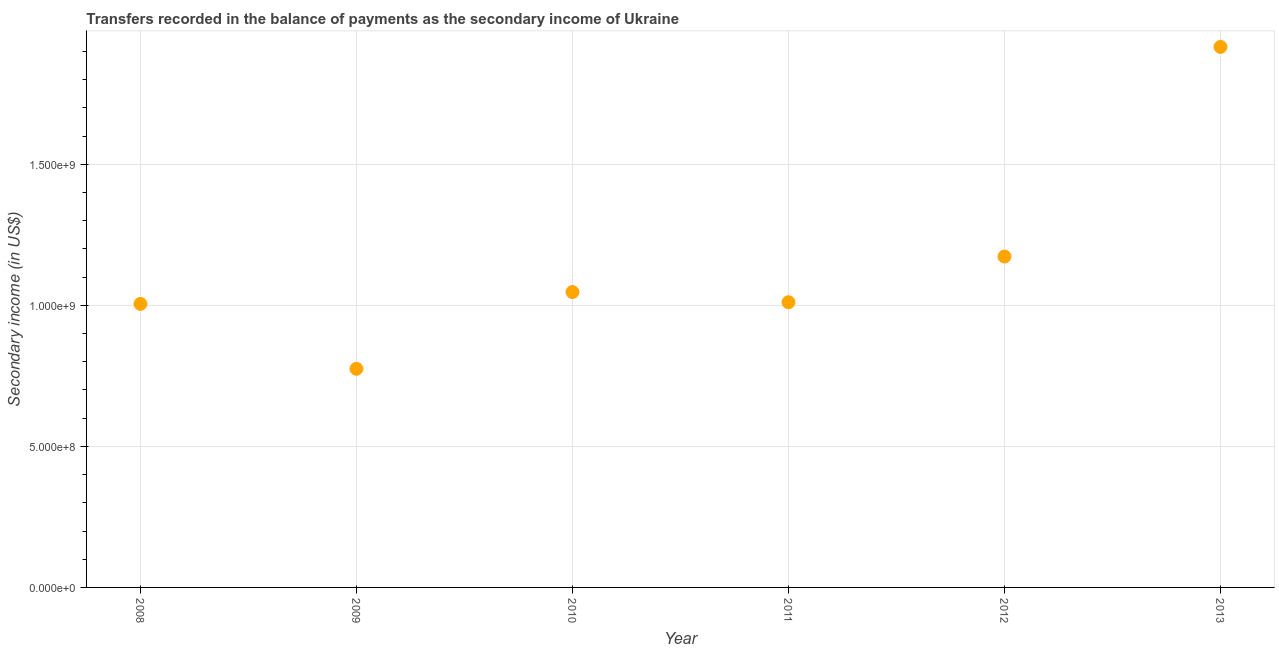What is the amount of secondary income in 2008?
Your answer should be very brief. 1.00e+09. Across all years, what is the maximum amount of secondary income?
Ensure brevity in your answer.  1.92e+09. Across all years, what is the minimum amount of secondary income?
Your answer should be compact. 7.75e+08. In which year was the amount of secondary income minimum?
Give a very brief answer. 2009. What is the sum of the amount of secondary income?
Provide a succinct answer. 6.93e+09. What is the difference between the amount of secondary income in 2008 and 2010?
Provide a short and direct response. -4.20e+07. What is the average amount of secondary income per year?
Offer a terse response. 1.15e+09. What is the median amount of secondary income?
Offer a very short reply. 1.03e+09. Do a majority of the years between 2013 and 2008 (inclusive) have amount of secondary income greater than 300000000 US$?
Offer a terse response. Yes. What is the ratio of the amount of secondary income in 2012 to that in 2013?
Provide a succinct answer. 0.61. Is the amount of secondary income in 2008 less than that in 2013?
Keep it short and to the point. Yes. Is the difference between the amount of secondary income in 2010 and 2011 greater than the difference between any two years?
Offer a very short reply. No. What is the difference between the highest and the second highest amount of secondary income?
Offer a very short reply. 7.43e+08. Is the sum of the amount of secondary income in 2008 and 2011 greater than the maximum amount of secondary income across all years?
Your answer should be very brief. Yes. What is the difference between the highest and the lowest amount of secondary income?
Provide a succinct answer. 1.14e+09. In how many years, is the amount of secondary income greater than the average amount of secondary income taken over all years?
Your answer should be very brief. 2. How many dotlines are there?
Give a very brief answer. 1. How many years are there in the graph?
Keep it short and to the point. 6. Does the graph contain any zero values?
Your answer should be very brief. No. What is the title of the graph?
Keep it short and to the point. Transfers recorded in the balance of payments as the secondary income of Ukraine. What is the label or title of the X-axis?
Your answer should be very brief. Year. What is the label or title of the Y-axis?
Your answer should be very brief. Secondary income (in US$). What is the Secondary income (in US$) in 2008?
Offer a very short reply. 1.00e+09. What is the Secondary income (in US$) in 2009?
Give a very brief answer. 7.75e+08. What is the Secondary income (in US$) in 2010?
Provide a succinct answer. 1.05e+09. What is the Secondary income (in US$) in 2011?
Keep it short and to the point. 1.01e+09. What is the Secondary income (in US$) in 2012?
Provide a short and direct response. 1.17e+09. What is the Secondary income (in US$) in 2013?
Give a very brief answer. 1.92e+09. What is the difference between the Secondary income (in US$) in 2008 and 2009?
Provide a succinct answer. 2.30e+08. What is the difference between the Secondary income (in US$) in 2008 and 2010?
Offer a terse response. -4.20e+07. What is the difference between the Secondary income (in US$) in 2008 and 2011?
Give a very brief answer. -6.00e+06. What is the difference between the Secondary income (in US$) in 2008 and 2012?
Your response must be concise. -1.68e+08. What is the difference between the Secondary income (in US$) in 2008 and 2013?
Offer a very short reply. -9.11e+08. What is the difference between the Secondary income (in US$) in 2009 and 2010?
Provide a succinct answer. -2.72e+08. What is the difference between the Secondary income (in US$) in 2009 and 2011?
Offer a terse response. -2.36e+08. What is the difference between the Secondary income (in US$) in 2009 and 2012?
Offer a terse response. -3.98e+08. What is the difference between the Secondary income (in US$) in 2009 and 2013?
Ensure brevity in your answer.  -1.14e+09. What is the difference between the Secondary income (in US$) in 2010 and 2011?
Provide a succinct answer. 3.60e+07. What is the difference between the Secondary income (in US$) in 2010 and 2012?
Ensure brevity in your answer.  -1.26e+08. What is the difference between the Secondary income (in US$) in 2010 and 2013?
Give a very brief answer. -8.69e+08. What is the difference between the Secondary income (in US$) in 2011 and 2012?
Ensure brevity in your answer.  -1.62e+08. What is the difference between the Secondary income (in US$) in 2011 and 2013?
Make the answer very short. -9.05e+08. What is the difference between the Secondary income (in US$) in 2012 and 2013?
Keep it short and to the point. -7.43e+08. What is the ratio of the Secondary income (in US$) in 2008 to that in 2009?
Provide a succinct answer. 1.3. What is the ratio of the Secondary income (in US$) in 2008 to that in 2012?
Offer a very short reply. 0.86. What is the ratio of the Secondary income (in US$) in 2008 to that in 2013?
Offer a very short reply. 0.53. What is the ratio of the Secondary income (in US$) in 2009 to that in 2010?
Ensure brevity in your answer.  0.74. What is the ratio of the Secondary income (in US$) in 2009 to that in 2011?
Offer a terse response. 0.77. What is the ratio of the Secondary income (in US$) in 2009 to that in 2012?
Your answer should be compact. 0.66. What is the ratio of the Secondary income (in US$) in 2009 to that in 2013?
Make the answer very short. 0.4. What is the ratio of the Secondary income (in US$) in 2010 to that in 2011?
Offer a very short reply. 1.04. What is the ratio of the Secondary income (in US$) in 2010 to that in 2012?
Give a very brief answer. 0.89. What is the ratio of the Secondary income (in US$) in 2010 to that in 2013?
Offer a very short reply. 0.55. What is the ratio of the Secondary income (in US$) in 2011 to that in 2012?
Keep it short and to the point. 0.86. What is the ratio of the Secondary income (in US$) in 2011 to that in 2013?
Offer a terse response. 0.53. What is the ratio of the Secondary income (in US$) in 2012 to that in 2013?
Your answer should be compact. 0.61. 